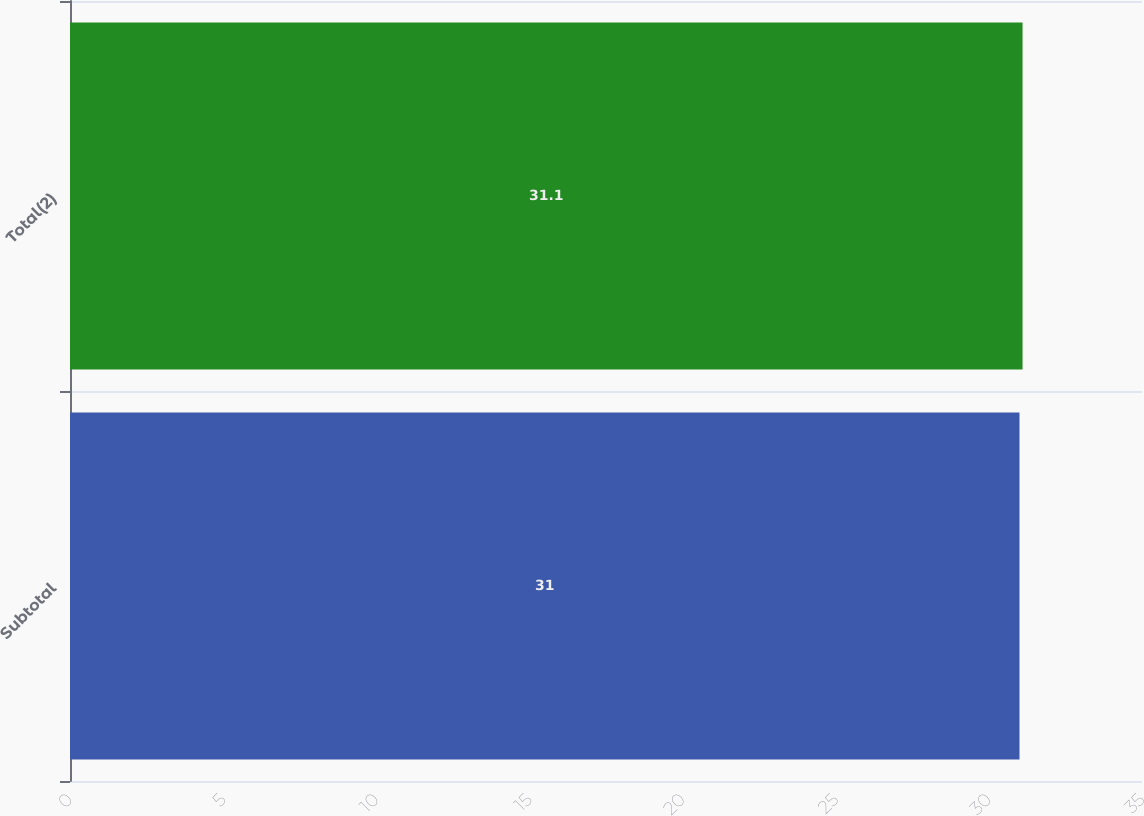<chart> <loc_0><loc_0><loc_500><loc_500><bar_chart><fcel>Subtotal<fcel>Total(2)<nl><fcel>31<fcel>31.1<nl></chart> 